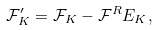Convert formula to latex. <formula><loc_0><loc_0><loc_500><loc_500>\mathcal { F } ^ { \prime } _ { K } = \mathcal { F } _ { K } - \mathcal { F } ^ { R } E _ { K } ,</formula> 